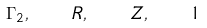Convert formula to latex. <formula><loc_0><loc_0><loc_500><loc_500>\Gamma _ { 2 } , \quad R , \quad Z , \quad 1</formula> 